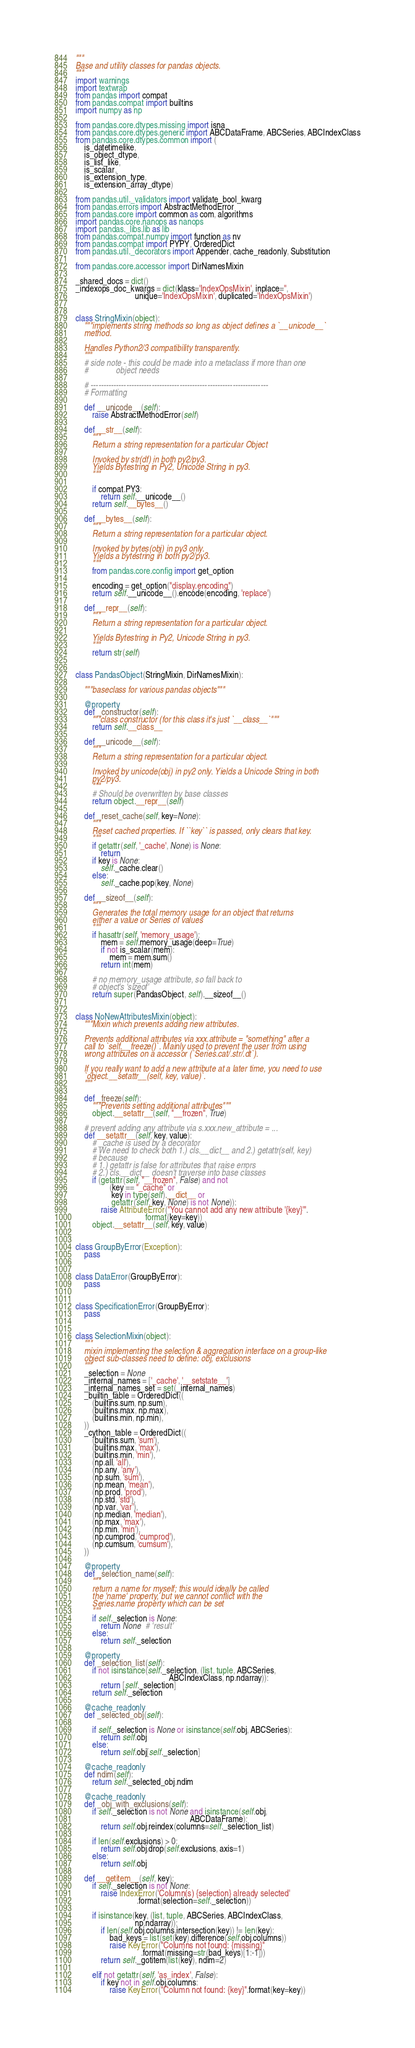<code> <loc_0><loc_0><loc_500><loc_500><_Python_>"""
Base and utility classes for pandas objects.
"""
import warnings
import textwrap
from pandas import compat
from pandas.compat import builtins
import numpy as np

from pandas.core.dtypes.missing import isna
from pandas.core.dtypes.generic import ABCDataFrame, ABCSeries, ABCIndexClass
from pandas.core.dtypes.common import (
    is_datetimelike,
    is_object_dtype,
    is_list_like,
    is_scalar,
    is_extension_type,
    is_extension_array_dtype)

from pandas.util._validators import validate_bool_kwarg
from pandas.errors import AbstractMethodError
from pandas.core import common as com, algorithms
import pandas.core.nanops as nanops
import pandas._libs.lib as lib
from pandas.compat.numpy import function as nv
from pandas.compat import PYPY, OrderedDict
from pandas.util._decorators import Appender, cache_readonly, Substitution

from pandas.core.accessor import DirNamesMixin

_shared_docs = dict()
_indexops_doc_kwargs = dict(klass='IndexOpsMixin', inplace='',
                            unique='IndexOpsMixin', duplicated='IndexOpsMixin')


class StringMixin(object):
    """implements string methods so long as object defines a `__unicode__`
    method.

    Handles Python2/3 compatibility transparently.
    """
    # side note - this could be made into a metaclass if more than one
    #             object needs

    # ----------------------------------------------------------------------
    # Formatting

    def __unicode__(self):
        raise AbstractMethodError(self)

    def __str__(self):
        """
        Return a string representation for a particular Object

        Invoked by str(df) in both py2/py3.
        Yields Bytestring in Py2, Unicode String in py3.
        """

        if compat.PY3:
            return self.__unicode__()
        return self.__bytes__()

    def __bytes__(self):
        """
        Return a string representation for a particular object.

        Invoked by bytes(obj) in py3 only.
        Yields a bytestring in both py2/py3.
        """
        from pandas.core.config import get_option

        encoding = get_option("display.encoding")
        return self.__unicode__().encode(encoding, 'replace')

    def __repr__(self):
        """
        Return a string representation for a particular object.

        Yields Bytestring in Py2, Unicode String in py3.
        """
        return str(self)


class PandasObject(StringMixin, DirNamesMixin):

    """baseclass for various pandas objects"""

    @property
    def _constructor(self):
        """class constructor (for this class it's just `__class__`"""
        return self.__class__

    def __unicode__(self):
        """
        Return a string representation for a particular object.

        Invoked by unicode(obj) in py2 only. Yields a Unicode String in both
        py2/py3.
        """
        # Should be overwritten by base classes
        return object.__repr__(self)

    def _reset_cache(self, key=None):
        """
        Reset cached properties. If ``key`` is passed, only clears that key.
        """
        if getattr(self, '_cache', None) is None:
            return
        if key is None:
            self._cache.clear()
        else:
            self._cache.pop(key, None)

    def __sizeof__(self):
        """
        Generates the total memory usage for an object that returns
        either a value or Series of values
        """
        if hasattr(self, 'memory_usage'):
            mem = self.memory_usage(deep=True)
            if not is_scalar(mem):
                mem = mem.sum()
            return int(mem)

        # no memory_usage attribute, so fall back to
        # object's 'sizeof'
        return super(PandasObject, self).__sizeof__()


class NoNewAttributesMixin(object):
    """Mixin which prevents adding new attributes.

    Prevents additional attributes via xxx.attribute = "something" after a
    call to `self.__freeze()`. Mainly used to prevent the user from using
    wrong attributes on a accessor (`Series.cat/.str/.dt`).

    If you really want to add a new attribute at a later time, you need to use
    `object.__setattr__(self, key, value)`.
    """

    def _freeze(self):
        """Prevents setting additional attributes"""
        object.__setattr__(self, "__frozen", True)

    # prevent adding any attribute via s.xxx.new_attribute = ...
    def __setattr__(self, key, value):
        # _cache is used by a decorator
        # We need to check both 1.) cls.__dict__ and 2.) getattr(self, key)
        # because
        # 1.) getattr is false for attributes that raise errors
        # 2.) cls.__dict__ doesn't traverse into base classes
        if (getattr(self, "__frozen", False) and not
                (key == "_cache" or
                 key in type(self).__dict__ or
                 getattr(self, key, None) is not None)):
            raise AttributeError("You cannot add any new attribute '{key}'".
                                 format(key=key))
        object.__setattr__(self, key, value)


class GroupByError(Exception):
    pass


class DataError(GroupByError):
    pass


class SpecificationError(GroupByError):
    pass


class SelectionMixin(object):
    """
    mixin implementing the selection & aggregation interface on a group-like
    object sub-classes need to define: obj, exclusions
    """
    _selection = None
    _internal_names = ['_cache', '__setstate__']
    _internal_names_set = set(_internal_names)
    _builtin_table = OrderedDict((
        (builtins.sum, np.sum),
        (builtins.max, np.max),
        (builtins.min, np.min),
    ))
    _cython_table = OrderedDict((
        (builtins.sum, 'sum'),
        (builtins.max, 'max'),
        (builtins.min, 'min'),
        (np.all, 'all'),
        (np.any, 'any'),
        (np.sum, 'sum'),
        (np.mean, 'mean'),
        (np.prod, 'prod'),
        (np.std, 'std'),
        (np.var, 'var'),
        (np.median, 'median'),
        (np.max, 'max'),
        (np.min, 'min'),
        (np.cumprod, 'cumprod'),
        (np.cumsum, 'cumsum'),
    ))

    @property
    def _selection_name(self):
        """
        return a name for myself; this would ideally be called
        the 'name' property, but we cannot conflict with the
        Series.name property which can be set
        """
        if self._selection is None:
            return None  # 'result'
        else:
            return self._selection

    @property
    def _selection_list(self):
        if not isinstance(self._selection, (list, tuple, ABCSeries,
                                            ABCIndexClass, np.ndarray)):
            return [self._selection]
        return self._selection

    @cache_readonly
    def _selected_obj(self):

        if self._selection is None or isinstance(self.obj, ABCSeries):
            return self.obj
        else:
            return self.obj[self._selection]

    @cache_readonly
    def ndim(self):
        return self._selected_obj.ndim

    @cache_readonly
    def _obj_with_exclusions(self):
        if self._selection is not None and isinstance(self.obj,
                                                      ABCDataFrame):
            return self.obj.reindex(columns=self._selection_list)

        if len(self.exclusions) > 0:
            return self.obj.drop(self.exclusions, axis=1)
        else:
            return self.obj

    def __getitem__(self, key):
        if self._selection is not None:
            raise IndexError('Column(s) {selection} already selected'
                             .format(selection=self._selection))

        if isinstance(key, (list, tuple, ABCSeries, ABCIndexClass,
                            np.ndarray)):
            if len(self.obj.columns.intersection(key)) != len(key):
                bad_keys = list(set(key).difference(self.obj.columns))
                raise KeyError("Columns not found: {missing}"
                               .format(missing=str(bad_keys)[1:-1]))
            return self._gotitem(list(key), ndim=2)

        elif not getattr(self, 'as_index', False):
            if key not in self.obj.columns:
                raise KeyError("Column not found: {key}".format(key=key))</code> 